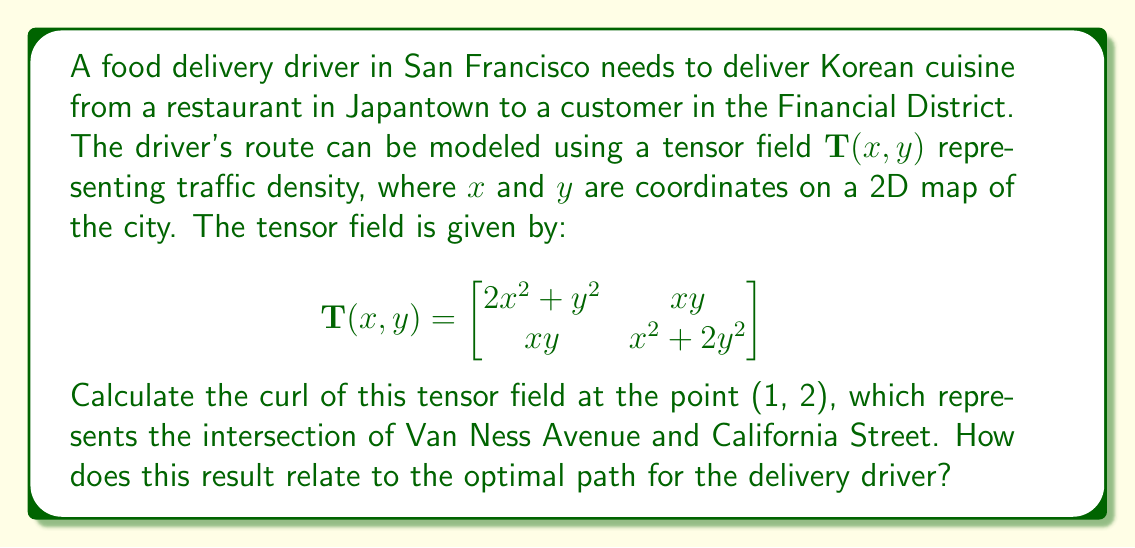Teach me how to tackle this problem. To solve this problem, we need to follow these steps:

1) The curl of a 2D tensor field $\mathbf{T}(x, y)$ is defined as:

   $$\text{curl}(\mathbf{T}) = \frac{\partial T_{yx}}{\partial x} - \frac{\partial T_{xy}}{\partial y}$$

   where $T_{xy}$ and $T_{yx}$ are the off-diagonal elements of the tensor.

2) In our case, $T_{xy} = T_{yx} = xy$. So we need to calculate:

   $$\text{curl}(\mathbf{T}) = \frac{\partial (xy)}{\partial x} - \frac{\partial (xy)}{\partial y}$$

3) Let's calculate each partial derivative:

   $\frac{\partial (xy)}{\partial x} = y$
   
   $\frac{\partial (xy)}{\partial y} = x$

4) Substituting these back into the curl equation:

   $$\text{curl}(\mathbf{T}) = y - x$$

5) Now, we need to evaluate this at the point (1, 2):

   $$\text{curl}(\mathbf{T})|_{(1,2)} = 2 - 1 = 1$$

6) The curl of a tensor field represents the rotation of the field at a given point. A non-zero curl indicates that the field is not conservative, meaning there's no potential function whose gradient gives this field.

7) For our delivery driver, this means that the optimal path is not simply the direct route from Japantown to the Financial District. The non-zero curl suggests that there are rotational traffic patterns that the driver should consider.

8) A positive curl at (1, 2) indicates a counterclockwise rotation in the traffic density at Van Ness and California. The driver might want to adjust their route to take advantage of this rotation, possibly by heading south on Van Ness before turning east towards the Financial District.
Answer: $\text{curl}(\mathbf{T})|_{(1,2)} = 1$; non-zero curl implies non-conservative field, suggesting indirect optimal path. 